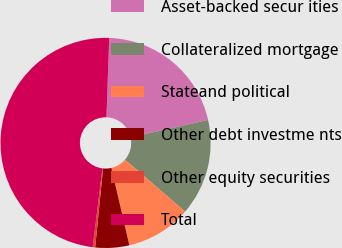<chart> <loc_0><loc_0><loc_500><loc_500><pie_chart><fcel>Asset-backed secur ities<fcel>Collateralized mortgage<fcel>Stateand political<fcel>Other debt investme nts<fcel>Other equity securities<fcel>Total<nl><fcel>20.94%<fcel>14.85%<fcel>10.03%<fcel>5.21%<fcel>0.38%<fcel>48.6%<nl></chart> 